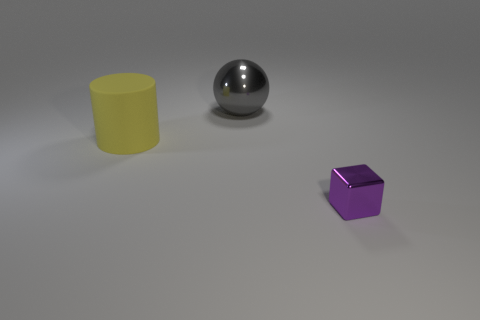Are there any other things that have the same material as the yellow cylinder?
Make the answer very short. No. What color is the thing that is right of the metallic thing behind the big yellow matte cylinder?
Your response must be concise. Purple. Is there a big matte thing that has the same color as the large matte cylinder?
Your response must be concise. No. There is a object that is right of the metallic thing behind the shiny object right of the large gray ball; what is its size?
Give a very brief answer. Small. Is the shape of the large yellow thing the same as the thing on the right side of the big gray shiny object?
Keep it short and to the point. No. How many other objects are the same size as the yellow thing?
Offer a terse response. 1. How big is the metallic thing that is to the left of the small shiny thing?
Provide a short and direct response. Large. How many big cylinders are made of the same material as the large sphere?
Give a very brief answer. 0. Do the thing in front of the big yellow matte cylinder and the large yellow thing have the same shape?
Provide a short and direct response. No. There is a large object that is in front of the sphere; what is its shape?
Ensure brevity in your answer.  Cylinder. 